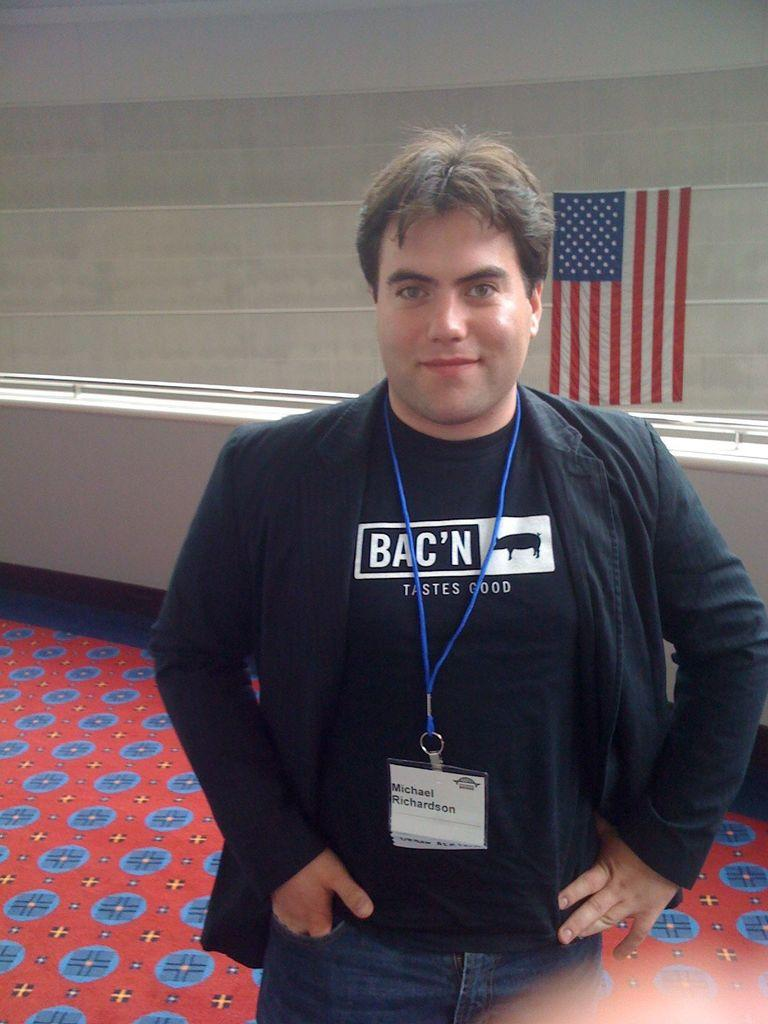What is the main subject of the image? There is a person in the image. What is the person wearing? The person is wearing a black dress. What can be seen on the person's chest? The person has a blue color ID card. What is the person doing in the image? The person is standing and posing for a photograph. What is visible in the background of the image? There is a wall and a flag in the background of the image. What time of day is it in the image, and how many sisters does the person have? The time of day cannot be determined from the image, and there is no information about the person's sisters. 